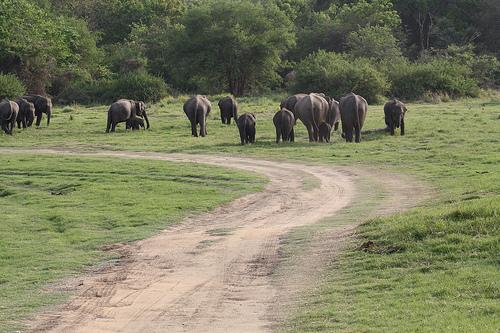Describe any complex reasoning or intricate relationships between objects or animals in the image. The elephants are placed in a setting that showcases a well-balanced natural environment, where the grass, trees, and sandy path create a harmonious habitat for them to thrive. How many elephants are in the image? Include adult and baby elephants. There are a total of 10 elephants in the image. Provide a simple caption for this image. A group of elephants in a field with green grass, trees, and a sandy path nearby. Count the number of specific objects and animals in the image: trees, grass, path, and elephants. Trees: 1, Grass: 6, Path: 1, Elephants: 10. Analyze the interactions between elephants and their environment in the image. The elephants are standing on the grass and interact with the environment by being near the trees, the bush, and the sandy path. Rate the quality of the image based on the clarity of the objects. The image's quality is quite high, as the objects and their positions are clearly identified and detailed. Describe the overall sentiment or mood of the image. The image conveys a peaceful and natural atmosphere, with elephants coexisting in harmony with the surrounding environment. What are the major objects or animals present in the image? Elephants, grass, trees, a path, and a bush. Identify the emotion evoked by the image. A sense of serenity and harmony with nature. Observe the majestic lion standing on the edge of the road. There is no mention of a lion in the image information, so it would not exist in the image. How would you assess the quality of the image? The image has good quality with clear objects and boundaries. Estimate the size of the baby elephant. Width:41 and Height:41. Find the pink flowers blooming near the grassy area. There is no mention of any flowers, let alone pink ones, in the image information. Thus, this object doesn't exist in the image. What is the color of the sand in the path? Brown. List the color attributes of the grass and trees. The grass is green, and the leaves of the trees are also green. Describe the main objects present in the image. Elephants, grass, trees, path and ground. Identify any text present in the image. There is no text present in the image. How many elephants can be seen in the image? 10 elephants. Which part of the image shows the edge of a road? X:154 Y:200 Width:70 Height:70. A group of tourists can be seen taking pictures near the elephants. There is no mention of tourists or people in the image information, making this object nonexistent in the image. Can you spot the people riding bicycles in the background? There is no mention of people or bicycles in the image information, making this object nonexistent in the image. Locate the area where the trees are short. X:173 Y:7 Width:185 Height:185. Describe any interaction occurring between the objects in the image. The elephants are walking and grazing in the field among the grass and trees. Analyze the overall sentiment of the image. Positive, as it shows elephants in a natural habitat. Give precise coordinates of trunk, head, and tail of an elephant. Trunk: X:38 Y:105 Width:25 Height:25, Head: X:35 Y:91 Width:35 Height:35, Tail: X:346 Y:102 Width:24 Height:24. What is the main focus of the image? A group of elephants in a field. A small river runs alongside a sandy path. Where is it? There is no mention of a river in the image information, making this object nonexistent in the image. Which area has the shortest grass? X:98 Y:182 Width:66 Height:66. Identify any unusual objects or anomalies in the image. No significant anomalies detected in the image. Describe the most prominent object in the image. A big grey elephant at X:92 Y:93 Width:78 Height:78. Pinpoint the object referred to as "the back end of a elephant." X:94 Y:94 Width:27 Height:27. Do you notice the blue bird perched on one of the trees? There is no mention of a blue bird in the image information, so it would not exist in the image. 